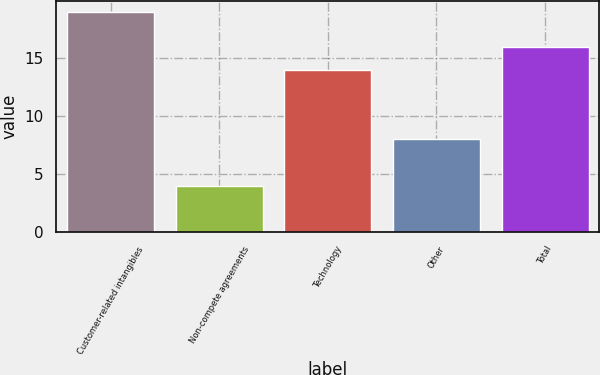Convert chart to OTSL. <chart><loc_0><loc_0><loc_500><loc_500><bar_chart><fcel>Customer-related intangibles<fcel>Non-compete agreements<fcel>Technology<fcel>Other<fcel>Total<nl><fcel>19<fcel>4<fcel>14<fcel>8<fcel>16<nl></chart> 